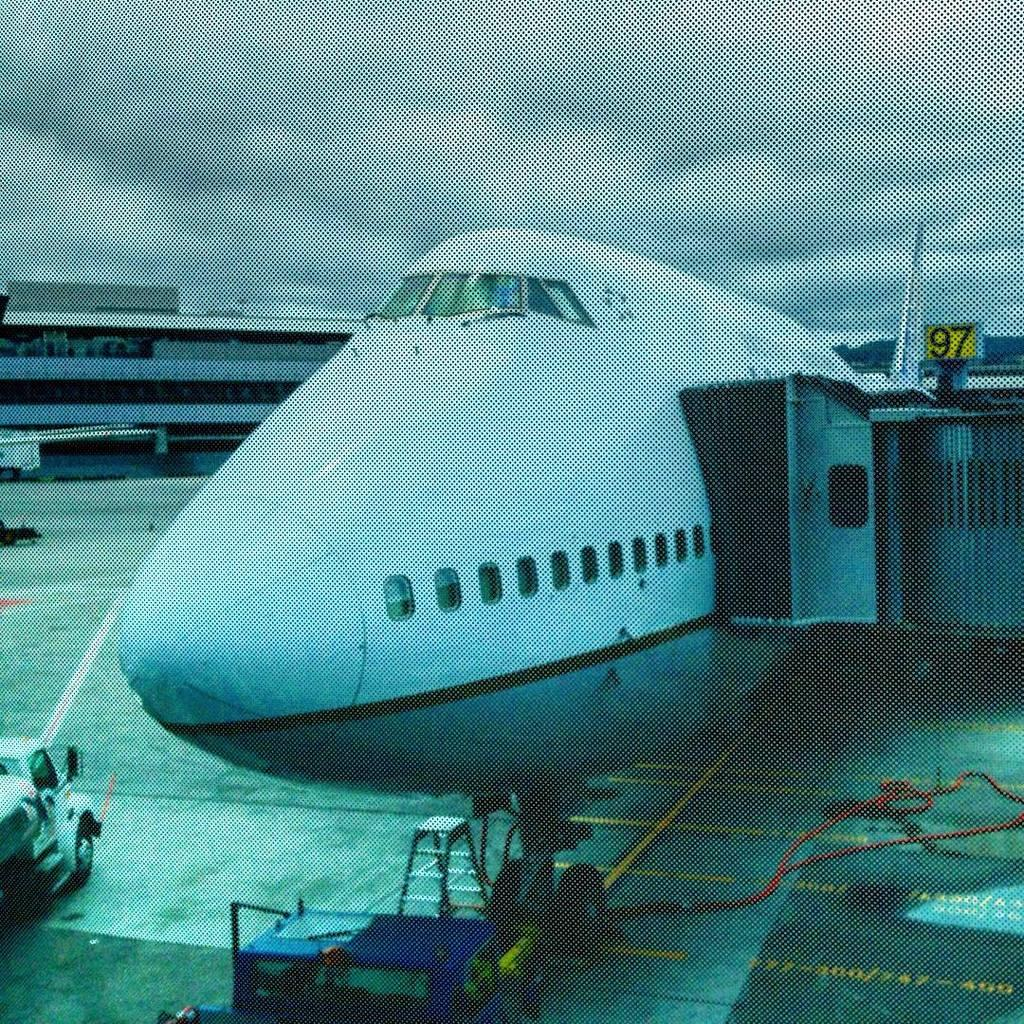Provide a one-sentence caption for the provided image. A plane is beside a yellow number ninety seven sign. 